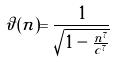Convert formula to latex. <formula><loc_0><loc_0><loc_500><loc_500>\vartheta ( n ) = \frac { 1 } { \sqrt { 1 - \frac { n ^ { 7 } } { c ^ { 7 } } } }</formula> 